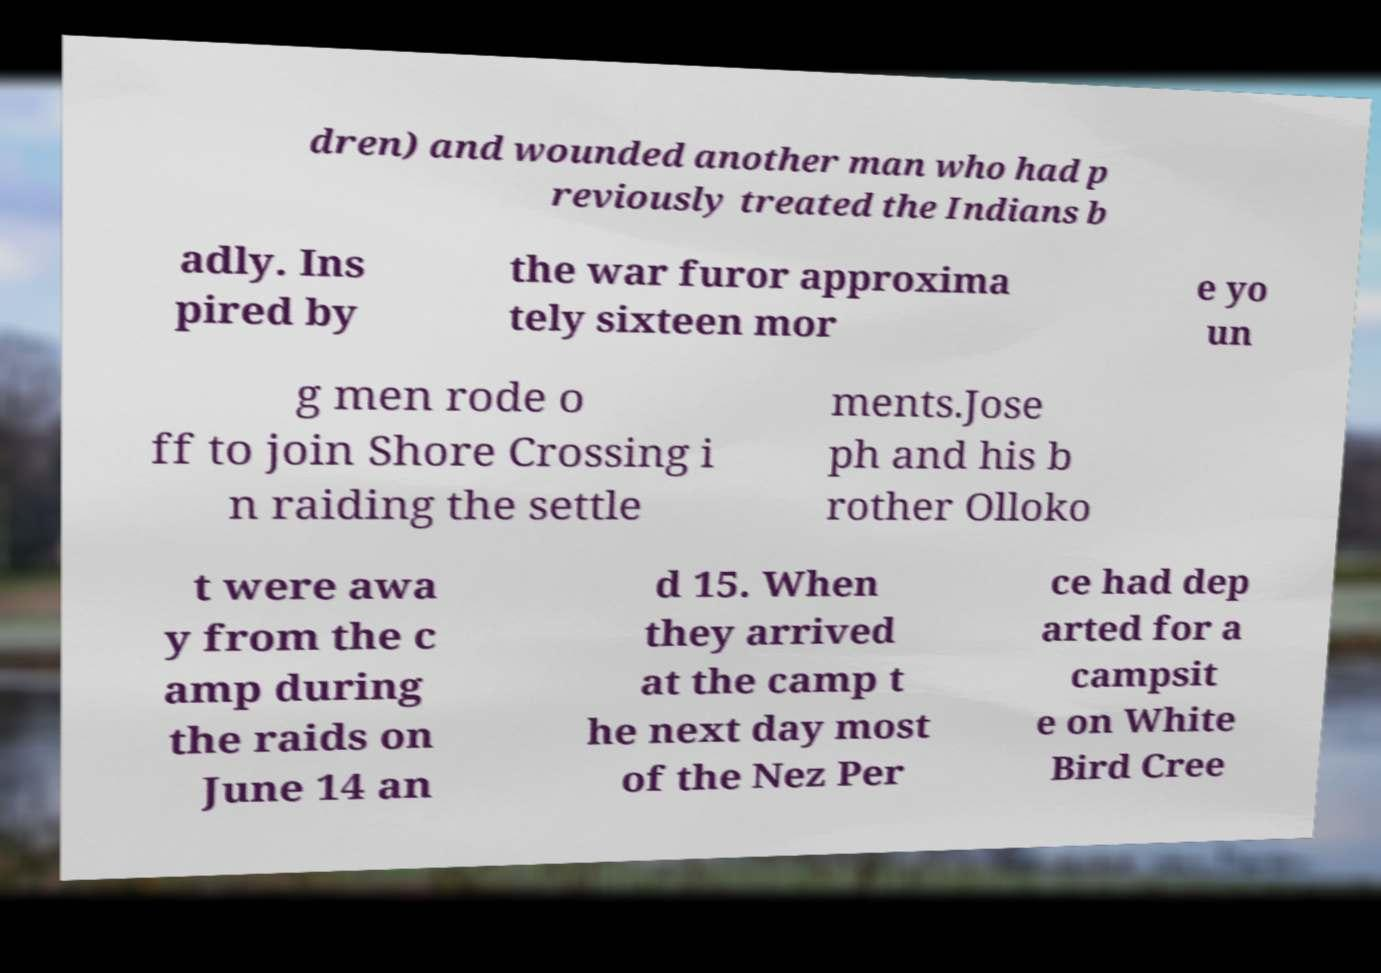Could you assist in decoding the text presented in this image and type it out clearly? dren) and wounded another man who had p reviously treated the Indians b adly. Ins pired by the war furor approxima tely sixteen mor e yo un g men rode o ff to join Shore Crossing i n raiding the settle ments.Jose ph and his b rother Olloko t were awa y from the c amp during the raids on June 14 an d 15. When they arrived at the camp t he next day most of the Nez Per ce had dep arted for a campsit e on White Bird Cree 